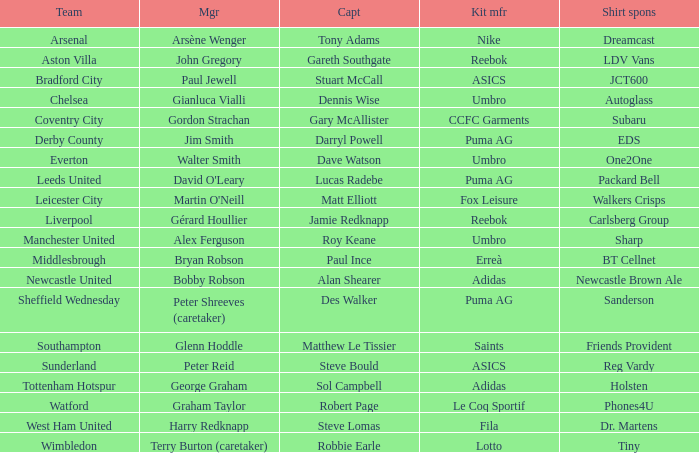Which Kit manufacturer sponsers Arsenal? Nike. 